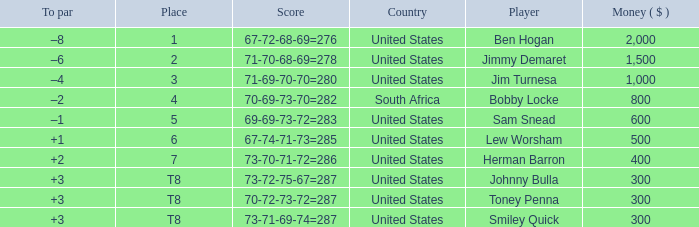What is the Score of the game of the Player in Place 4? 70-69-73-70=282. 